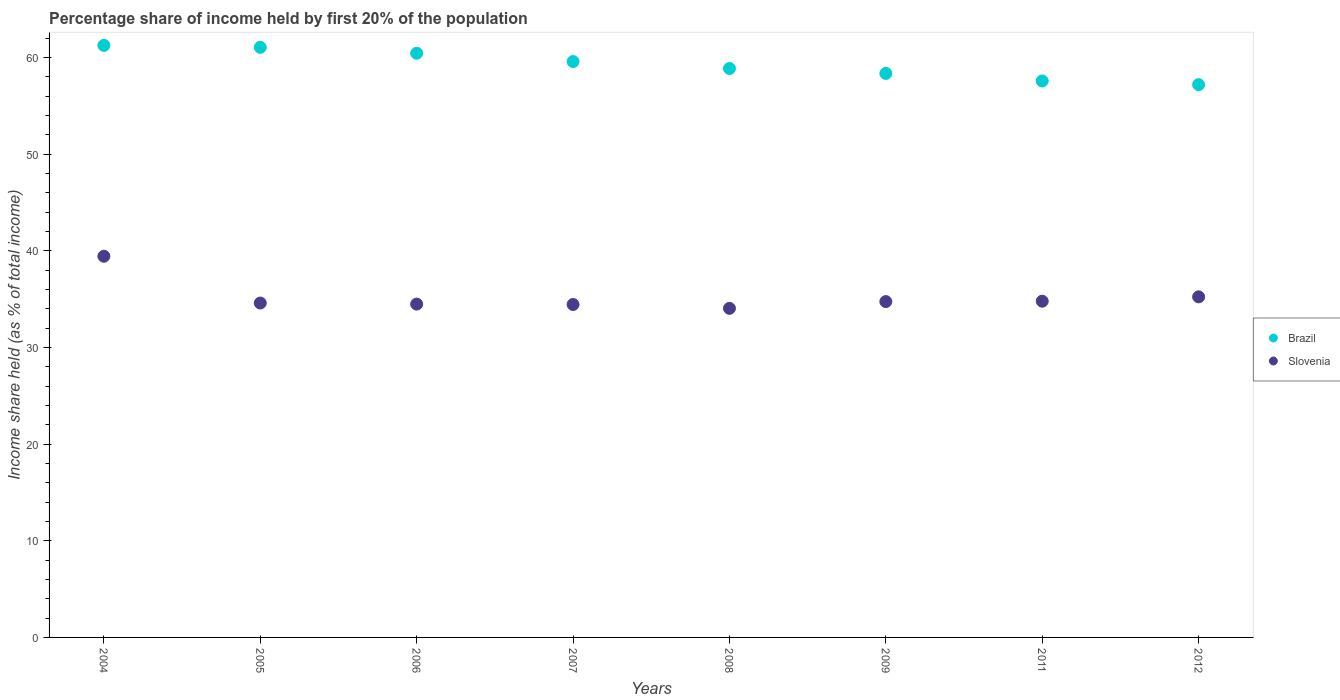How many different coloured dotlines are there?
Ensure brevity in your answer.  2. What is the share of income held by first 20% of the population in Slovenia in 2011?
Offer a terse response. 34.78. Across all years, what is the maximum share of income held by first 20% of the population in Brazil?
Make the answer very short. 61.24. Across all years, what is the minimum share of income held by first 20% of the population in Brazil?
Make the answer very short. 57.18. In which year was the share of income held by first 20% of the population in Brazil maximum?
Give a very brief answer. 2004. In which year was the share of income held by first 20% of the population in Slovenia minimum?
Your answer should be very brief. 2008. What is the total share of income held by first 20% of the population in Brazil in the graph?
Your answer should be very brief. 474.21. What is the difference between the share of income held by first 20% of the population in Slovenia in 2004 and that in 2006?
Give a very brief answer. 4.95. What is the difference between the share of income held by first 20% of the population in Slovenia in 2011 and the share of income held by first 20% of the population in Brazil in 2007?
Provide a succinct answer. -24.79. What is the average share of income held by first 20% of the population in Slovenia per year?
Offer a terse response. 35.22. In the year 2004, what is the difference between the share of income held by first 20% of the population in Slovenia and share of income held by first 20% of the population in Brazil?
Provide a succinct answer. -21.81. What is the ratio of the share of income held by first 20% of the population in Slovenia in 2011 to that in 2012?
Offer a terse response. 0.99. Is the share of income held by first 20% of the population in Slovenia in 2006 less than that in 2011?
Provide a succinct answer. Yes. What is the difference between the highest and the second highest share of income held by first 20% of the population in Slovenia?
Your answer should be very brief. 4.2. What is the difference between the highest and the lowest share of income held by first 20% of the population in Brazil?
Keep it short and to the point. 4.06. Is the share of income held by first 20% of the population in Brazil strictly greater than the share of income held by first 20% of the population in Slovenia over the years?
Offer a very short reply. Yes. Is the share of income held by first 20% of the population in Brazil strictly less than the share of income held by first 20% of the population in Slovenia over the years?
Offer a terse response. No. How many dotlines are there?
Make the answer very short. 2. What is the difference between two consecutive major ticks on the Y-axis?
Make the answer very short. 10. Are the values on the major ticks of Y-axis written in scientific E-notation?
Your response must be concise. No. Does the graph contain any zero values?
Your answer should be very brief. No. Does the graph contain grids?
Your answer should be compact. No. Where does the legend appear in the graph?
Give a very brief answer. Center right. How are the legend labels stacked?
Your answer should be very brief. Vertical. What is the title of the graph?
Your response must be concise. Percentage share of income held by first 20% of the population. What is the label or title of the X-axis?
Ensure brevity in your answer.  Years. What is the label or title of the Y-axis?
Your answer should be very brief. Income share held (as % of total income). What is the Income share held (as % of total income) of Brazil in 2004?
Make the answer very short. 61.24. What is the Income share held (as % of total income) in Slovenia in 2004?
Ensure brevity in your answer.  39.43. What is the Income share held (as % of total income) of Brazil in 2005?
Your answer should be very brief. 61.04. What is the Income share held (as % of total income) in Slovenia in 2005?
Your answer should be compact. 34.59. What is the Income share held (as % of total income) of Brazil in 2006?
Your response must be concise. 60.43. What is the Income share held (as % of total income) in Slovenia in 2006?
Your answer should be compact. 34.48. What is the Income share held (as % of total income) of Brazil in 2007?
Your response must be concise. 59.57. What is the Income share held (as % of total income) of Slovenia in 2007?
Provide a succinct answer. 34.44. What is the Income share held (as % of total income) of Brazil in 2008?
Your response must be concise. 58.85. What is the Income share held (as % of total income) in Slovenia in 2008?
Provide a short and direct response. 34.04. What is the Income share held (as % of total income) in Brazil in 2009?
Provide a short and direct response. 58.34. What is the Income share held (as % of total income) of Slovenia in 2009?
Keep it short and to the point. 34.74. What is the Income share held (as % of total income) of Brazil in 2011?
Make the answer very short. 57.56. What is the Income share held (as % of total income) of Slovenia in 2011?
Provide a succinct answer. 34.78. What is the Income share held (as % of total income) in Brazil in 2012?
Offer a terse response. 57.18. What is the Income share held (as % of total income) of Slovenia in 2012?
Your answer should be very brief. 35.23. Across all years, what is the maximum Income share held (as % of total income) of Brazil?
Give a very brief answer. 61.24. Across all years, what is the maximum Income share held (as % of total income) of Slovenia?
Offer a terse response. 39.43. Across all years, what is the minimum Income share held (as % of total income) of Brazil?
Offer a terse response. 57.18. Across all years, what is the minimum Income share held (as % of total income) of Slovenia?
Make the answer very short. 34.04. What is the total Income share held (as % of total income) in Brazil in the graph?
Offer a terse response. 474.21. What is the total Income share held (as % of total income) in Slovenia in the graph?
Your answer should be compact. 281.73. What is the difference between the Income share held (as % of total income) in Slovenia in 2004 and that in 2005?
Your answer should be compact. 4.84. What is the difference between the Income share held (as % of total income) of Brazil in 2004 and that in 2006?
Ensure brevity in your answer.  0.81. What is the difference between the Income share held (as % of total income) in Slovenia in 2004 and that in 2006?
Your answer should be compact. 4.95. What is the difference between the Income share held (as % of total income) in Brazil in 2004 and that in 2007?
Your answer should be compact. 1.67. What is the difference between the Income share held (as % of total income) of Slovenia in 2004 and that in 2007?
Make the answer very short. 4.99. What is the difference between the Income share held (as % of total income) of Brazil in 2004 and that in 2008?
Ensure brevity in your answer.  2.39. What is the difference between the Income share held (as % of total income) in Slovenia in 2004 and that in 2008?
Offer a very short reply. 5.39. What is the difference between the Income share held (as % of total income) in Slovenia in 2004 and that in 2009?
Provide a short and direct response. 4.69. What is the difference between the Income share held (as % of total income) of Brazil in 2004 and that in 2011?
Give a very brief answer. 3.68. What is the difference between the Income share held (as % of total income) of Slovenia in 2004 and that in 2011?
Keep it short and to the point. 4.65. What is the difference between the Income share held (as % of total income) of Brazil in 2004 and that in 2012?
Your response must be concise. 4.06. What is the difference between the Income share held (as % of total income) in Slovenia in 2004 and that in 2012?
Keep it short and to the point. 4.2. What is the difference between the Income share held (as % of total income) in Brazil in 2005 and that in 2006?
Your response must be concise. 0.61. What is the difference between the Income share held (as % of total income) in Slovenia in 2005 and that in 2006?
Make the answer very short. 0.11. What is the difference between the Income share held (as % of total income) of Brazil in 2005 and that in 2007?
Your response must be concise. 1.47. What is the difference between the Income share held (as % of total income) of Slovenia in 2005 and that in 2007?
Your response must be concise. 0.15. What is the difference between the Income share held (as % of total income) in Brazil in 2005 and that in 2008?
Your answer should be very brief. 2.19. What is the difference between the Income share held (as % of total income) in Slovenia in 2005 and that in 2008?
Keep it short and to the point. 0.55. What is the difference between the Income share held (as % of total income) of Slovenia in 2005 and that in 2009?
Ensure brevity in your answer.  -0.15. What is the difference between the Income share held (as % of total income) of Brazil in 2005 and that in 2011?
Your answer should be very brief. 3.48. What is the difference between the Income share held (as % of total income) of Slovenia in 2005 and that in 2011?
Offer a very short reply. -0.19. What is the difference between the Income share held (as % of total income) in Brazil in 2005 and that in 2012?
Offer a terse response. 3.86. What is the difference between the Income share held (as % of total income) of Slovenia in 2005 and that in 2012?
Ensure brevity in your answer.  -0.64. What is the difference between the Income share held (as % of total income) of Brazil in 2006 and that in 2007?
Your answer should be compact. 0.86. What is the difference between the Income share held (as % of total income) in Brazil in 2006 and that in 2008?
Give a very brief answer. 1.58. What is the difference between the Income share held (as % of total income) in Slovenia in 2006 and that in 2008?
Give a very brief answer. 0.44. What is the difference between the Income share held (as % of total income) in Brazil in 2006 and that in 2009?
Your response must be concise. 2.09. What is the difference between the Income share held (as % of total income) in Slovenia in 2006 and that in 2009?
Your response must be concise. -0.26. What is the difference between the Income share held (as % of total income) in Brazil in 2006 and that in 2011?
Offer a very short reply. 2.87. What is the difference between the Income share held (as % of total income) of Slovenia in 2006 and that in 2012?
Offer a very short reply. -0.75. What is the difference between the Income share held (as % of total income) of Brazil in 2007 and that in 2008?
Offer a terse response. 0.72. What is the difference between the Income share held (as % of total income) in Slovenia in 2007 and that in 2008?
Keep it short and to the point. 0.4. What is the difference between the Income share held (as % of total income) in Brazil in 2007 and that in 2009?
Give a very brief answer. 1.23. What is the difference between the Income share held (as % of total income) of Slovenia in 2007 and that in 2009?
Ensure brevity in your answer.  -0.3. What is the difference between the Income share held (as % of total income) in Brazil in 2007 and that in 2011?
Offer a very short reply. 2.01. What is the difference between the Income share held (as % of total income) in Slovenia in 2007 and that in 2011?
Provide a short and direct response. -0.34. What is the difference between the Income share held (as % of total income) of Brazil in 2007 and that in 2012?
Offer a very short reply. 2.39. What is the difference between the Income share held (as % of total income) in Slovenia in 2007 and that in 2012?
Give a very brief answer. -0.79. What is the difference between the Income share held (as % of total income) of Brazil in 2008 and that in 2009?
Provide a succinct answer. 0.51. What is the difference between the Income share held (as % of total income) of Slovenia in 2008 and that in 2009?
Make the answer very short. -0.7. What is the difference between the Income share held (as % of total income) of Brazil in 2008 and that in 2011?
Keep it short and to the point. 1.29. What is the difference between the Income share held (as % of total income) in Slovenia in 2008 and that in 2011?
Give a very brief answer. -0.74. What is the difference between the Income share held (as % of total income) in Brazil in 2008 and that in 2012?
Make the answer very short. 1.67. What is the difference between the Income share held (as % of total income) in Slovenia in 2008 and that in 2012?
Offer a very short reply. -1.19. What is the difference between the Income share held (as % of total income) in Brazil in 2009 and that in 2011?
Your response must be concise. 0.78. What is the difference between the Income share held (as % of total income) of Slovenia in 2009 and that in 2011?
Make the answer very short. -0.04. What is the difference between the Income share held (as % of total income) of Brazil in 2009 and that in 2012?
Provide a short and direct response. 1.16. What is the difference between the Income share held (as % of total income) in Slovenia in 2009 and that in 2012?
Ensure brevity in your answer.  -0.49. What is the difference between the Income share held (as % of total income) in Brazil in 2011 and that in 2012?
Your answer should be very brief. 0.38. What is the difference between the Income share held (as % of total income) in Slovenia in 2011 and that in 2012?
Provide a short and direct response. -0.45. What is the difference between the Income share held (as % of total income) of Brazil in 2004 and the Income share held (as % of total income) of Slovenia in 2005?
Provide a succinct answer. 26.65. What is the difference between the Income share held (as % of total income) of Brazil in 2004 and the Income share held (as % of total income) of Slovenia in 2006?
Offer a very short reply. 26.76. What is the difference between the Income share held (as % of total income) of Brazil in 2004 and the Income share held (as % of total income) of Slovenia in 2007?
Provide a succinct answer. 26.8. What is the difference between the Income share held (as % of total income) of Brazil in 2004 and the Income share held (as % of total income) of Slovenia in 2008?
Ensure brevity in your answer.  27.2. What is the difference between the Income share held (as % of total income) in Brazil in 2004 and the Income share held (as % of total income) in Slovenia in 2009?
Give a very brief answer. 26.5. What is the difference between the Income share held (as % of total income) of Brazil in 2004 and the Income share held (as % of total income) of Slovenia in 2011?
Make the answer very short. 26.46. What is the difference between the Income share held (as % of total income) in Brazil in 2004 and the Income share held (as % of total income) in Slovenia in 2012?
Keep it short and to the point. 26.01. What is the difference between the Income share held (as % of total income) in Brazil in 2005 and the Income share held (as % of total income) in Slovenia in 2006?
Your answer should be compact. 26.56. What is the difference between the Income share held (as % of total income) in Brazil in 2005 and the Income share held (as % of total income) in Slovenia in 2007?
Ensure brevity in your answer.  26.6. What is the difference between the Income share held (as % of total income) in Brazil in 2005 and the Income share held (as % of total income) in Slovenia in 2009?
Provide a succinct answer. 26.3. What is the difference between the Income share held (as % of total income) of Brazil in 2005 and the Income share held (as % of total income) of Slovenia in 2011?
Your response must be concise. 26.26. What is the difference between the Income share held (as % of total income) of Brazil in 2005 and the Income share held (as % of total income) of Slovenia in 2012?
Offer a very short reply. 25.81. What is the difference between the Income share held (as % of total income) in Brazil in 2006 and the Income share held (as % of total income) in Slovenia in 2007?
Provide a short and direct response. 25.99. What is the difference between the Income share held (as % of total income) in Brazil in 2006 and the Income share held (as % of total income) in Slovenia in 2008?
Your response must be concise. 26.39. What is the difference between the Income share held (as % of total income) of Brazil in 2006 and the Income share held (as % of total income) of Slovenia in 2009?
Your answer should be compact. 25.69. What is the difference between the Income share held (as % of total income) of Brazil in 2006 and the Income share held (as % of total income) of Slovenia in 2011?
Ensure brevity in your answer.  25.65. What is the difference between the Income share held (as % of total income) of Brazil in 2006 and the Income share held (as % of total income) of Slovenia in 2012?
Your answer should be very brief. 25.2. What is the difference between the Income share held (as % of total income) in Brazil in 2007 and the Income share held (as % of total income) in Slovenia in 2008?
Give a very brief answer. 25.53. What is the difference between the Income share held (as % of total income) of Brazil in 2007 and the Income share held (as % of total income) of Slovenia in 2009?
Provide a succinct answer. 24.83. What is the difference between the Income share held (as % of total income) of Brazil in 2007 and the Income share held (as % of total income) of Slovenia in 2011?
Ensure brevity in your answer.  24.79. What is the difference between the Income share held (as % of total income) of Brazil in 2007 and the Income share held (as % of total income) of Slovenia in 2012?
Ensure brevity in your answer.  24.34. What is the difference between the Income share held (as % of total income) in Brazil in 2008 and the Income share held (as % of total income) in Slovenia in 2009?
Your answer should be very brief. 24.11. What is the difference between the Income share held (as % of total income) of Brazil in 2008 and the Income share held (as % of total income) of Slovenia in 2011?
Keep it short and to the point. 24.07. What is the difference between the Income share held (as % of total income) in Brazil in 2008 and the Income share held (as % of total income) in Slovenia in 2012?
Keep it short and to the point. 23.62. What is the difference between the Income share held (as % of total income) in Brazil in 2009 and the Income share held (as % of total income) in Slovenia in 2011?
Give a very brief answer. 23.56. What is the difference between the Income share held (as % of total income) of Brazil in 2009 and the Income share held (as % of total income) of Slovenia in 2012?
Keep it short and to the point. 23.11. What is the difference between the Income share held (as % of total income) of Brazil in 2011 and the Income share held (as % of total income) of Slovenia in 2012?
Make the answer very short. 22.33. What is the average Income share held (as % of total income) of Brazil per year?
Provide a succinct answer. 59.28. What is the average Income share held (as % of total income) in Slovenia per year?
Make the answer very short. 35.22. In the year 2004, what is the difference between the Income share held (as % of total income) of Brazil and Income share held (as % of total income) of Slovenia?
Keep it short and to the point. 21.81. In the year 2005, what is the difference between the Income share held (as % of total income) of Brazil and Income share held (as % of total income) of Slovenia?
Offer a terse response. 26.45. In the year 2006, what is the difference between the Income share held (as % of total income) in Brazil and Income share held (as % of total income) in Slovenia?
Ensure brevity in your answer.  25.95. In the year 2007, what is the difference between the Income share held (as % of total income) of Brazil and Income share held (as % of total income) of Slovenia?
Give a very brief answer. 25.13. In the year 2008, what is the difference between the Income share held (as % of total income) in Brazil and Income share held (as % of total income) in Slovenia?
Provide a short and direct response. 24.81. In the year 2009, what is the difference between the Income share held (as % of total income) of Brazil and Income share held (as % of total income) of Slovenia?
Ensure brevity in your answer.  23.6. In the year 2011, what is the difference between the Income share held (as % of total income) of Brazil and Income share held (as % of total income) of Slovenia?
Provide a succinct answer. 22.78. In the year 2012, what is the difference between the Income share held (as % of total income) in Brazil and Income share held (as % of total income) in Slovenia?
Provide a short and direct response. 21.95. What is the ratio of the Income share held (as % of total income) in Brazil in 2004 to that in 2005?
Ensure brevity in your answer.  1. What is the ratio of the Income share held (as % of total income) of Slovenia in 2004 to that in 2005?
Give a very brief answer. 1.14. What is the ratio of the Income share held (as % of total income) in Brazil in 2004 to that in 2006?
Keep it short and to the point. 1.01. What is the ratio of the Income share held (as % of total income) of Slovenia in 2004 to that in 2006?
Provide a short and direct response. 1.14. What is the ratio of the Income share held (as % of total income) in Brazil in 2004 to that in 2007?
Your answer should be compact. 1.03. What is the ratio of the Income share held (as % of total income) of Slovenia in 2004 to that in 2007?
Your answer should be compact. 1.14. What is the ratio of the Income share held (as % of total income) of Brazil in 2004 to that in 2008?
Keep it short and to the point. 1.04. What is the ratio of the Income share held (as % of total income) of Slovenia in 2004 to that in 2008?
Keep it short and to the point. 1.16. What is the ratio of the Income share held (as % of total income) in Brazil in 2004 to that in 2009?
Offer a very short reply. 1.05. What is the ratio of the Income share held (as % of total income) in Slovenia in 2004 to that in 2009?
Make the answer very short. 1.14. What is the ratio of the Income share held (as % of total income) of Brazil in 2004 to that in 2011?
Offer a very short reply. 1.06. What is the ratio of the Income share held (as % of total income) in Slovenia in 2004 to that in 2011?
Make the answer very short. 1.13. What is the ratio of the Income share held (as % of total income) in Brazil in 2004 to that in 2012?
Ensure brevity in your answer.  1.07. What is the ratio of the Income share held (as % of total income) of Slovenia in 2004 to that in 2012?
Ensure brevity in your answer.  1.12. What is the ratio of the Income share held (as % of total income) in Brazil in 2005 to that in 2007?
Provide a short and direct response. 1.02. What is the ratio of the Income share held (as % of total income) of Slovenia in 2005 to that in 2007?
Your answer should be compact. 1. What is the ratio of the Income share held (as % of total income) in Brazil in 2005 to that in 2008?
Provide a short and direct response. 1.04. What is the ratio of the Income share held (as % of total income) in Slovenia in 2005 to that in 2008?
Provide a short and direct response. 1.02. What is the ratio of the Income share held (as % of total income) of Brazil in 2005 to that in 2009?
Keep it short and to the point. 1.05. What is the ratio of the Income share held (as % of total income) in Brazil in 2005 to that in 2011?
Ensure brevity in your answer.  1.06. What is the ratio of the Income share held (as % of total income) in Slovenia in 2005 to that in 2011?
Offer a very short reply. 0.99. What is the ratio of the Income share held (as % of total income) of Brazil in 2005 to that in 2012?
Give a very brief answer. 1.07. What is the ratio of the Income share held (as % of total income) in Slovenia in 2005 to that in 2012?
Provide a short and direct response. 0.98. What is the ratio of the Income share held (as % of total income) of Brazil in 2006 to that in 2007?
Make the answer very short. 1.01. What is the ratio of the Income share held (as % of total income) of Brazil in 2006 to that in 2008?
Ensure brevity in your answer.  1.03. What is the ratio of the Income share held (as % of total income) in Slovenia in 2006 to that in 2008?
Give a very brief answer. 1.01. What is the ratio of the Income share held (as % of total income) in Brazil in 2006 to that in 2009?
Offer a terse response. 1.04. What is the ratio of the Income share held (as % of total income) of Slovenia in 2006 to that in 2009?
Provide a short and direct response. 0.99. What is the ratio of the Income share held (as % of total income) in Brazil in 2006 to that in 2011?
Your answer should be compact. 1.05. What is the ratio of the Income share held (as % of total income) of Slovenia in 2006 to that in 2011?
Your answer should be compact. 0.99. What is the ratio of the Income share held (as % of total income) in Brazil in 2006 to that in 2012?
Make the answer very short. 1.06. What is the ratio of the Income share held (as % of total income) in Slovenia in 2006 to that in 2012?
Your answer should be very brief. 0.98. What is the ratio of the Income share held (as % of total income) in Brazil in 2007 to that in 2008?
Provide a short and direct response. 1.01. What is the ratio of the Income share held (as % of total income) of Slovenia in 2007 to that in 2008?
Offer a very short reply. 1.01. What is the ratio of the Income share held (as % of total income) in Brazil in 2007 to that in 2009?
Give a very brief answer. 1.02. What is the ratio of the Income share held (as % of total income) in Slovenia in 2007 to that in 2009?
Your response must be concise. 0.99. What is the ratio of the Income share held (as % of total income) of Brazil in 2007 to that in 2011?
Keep it short and to the point. 1.03. What is the ratio of the Income share held (as % of total income) of Slovenia in 2007 to that in 2011?
Provide a short and direct response. 0.99. What is the ratio of the Income share held (as % of total income) in Brazil in 2007 to that in 2012?
Your answer should be compact. 1.04. What is the ratio of the Income share held (as % of total income) of Slovenia in 2007 to that in 2012?
Make the answer very short. 0.98. What is the ratio of the Income share held (as % of total income) of Brazil in 2008 to that in 2009?
Give a very brief answer. 1.01. What is the ratio of the Income share held (as % of total income) of Slovenia in 2008 to that in 2009?
Your answer should be very brief. 0.98. What is the ratio of the Income share held (as % of total income) in Brazil in 2008 to that in 2011?
Your response must be concise. 1.02. What is the ratio of the Income share held (as % of total income) of Slovenia in 2008 to that in 2011?
Your answer should be very brief. 0.98. What is the ratio of the Income share held (as % of total income) of Brazil in 2008 to that in 2012?
Ensure brevity in your answer.  1.03. What is the ratio of the Income share held (as % of total income) of Slovenia in 2008 to that in 2012?
Your response must be concise. 0.97. What is the ratio of the Income share held (as % of total income) in Brazil in 2009 to that in 2011?
Give a very brief answer. 1.01. What is the ratio of the Income share held (as % of total income) of Brazil in 2009 to that in 2012?
Make the answer very short. 1.02. What is the ratio of the Income share held (as % of total income) in Slovenia in 2009 to that in 2012?
Offer a very short reply. 0.99. What is the ratio of the Income share held (as % of total income) of Brazil in 2011 to that in 2012?
Your answer should be compact. 1.01. What is the ratio of the Income share held (as % of total income) of Slovenia in 2011 to that in 2012?
Make the answer very short. 0.99. What is the difference between the highest and the second highest Income share held (as % of total income) in Brazil?
Your answer should be compact. 0.2. What is the difference between the highest and the second highest Income share held (as % of total income) in Slovenia?
Provide a short and direct response. 4.2. What is the difference between the highest and the lowest Income share held (as % of total income) of Brazil?
Your answer should be compact. 4.06. What is the difference between the highest and the lowest Income share held (as % of total income) of Slovenia?
Provide a succinct answer. 5.39. 